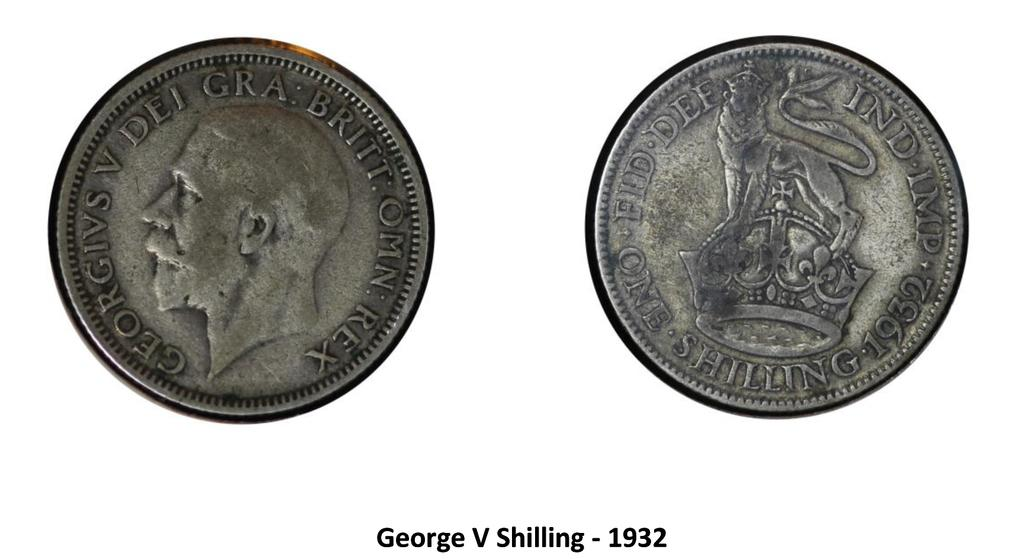Provide a one-sentence caption for the provided image. 2 coins from 1932 one is called george the other is called shilling. 